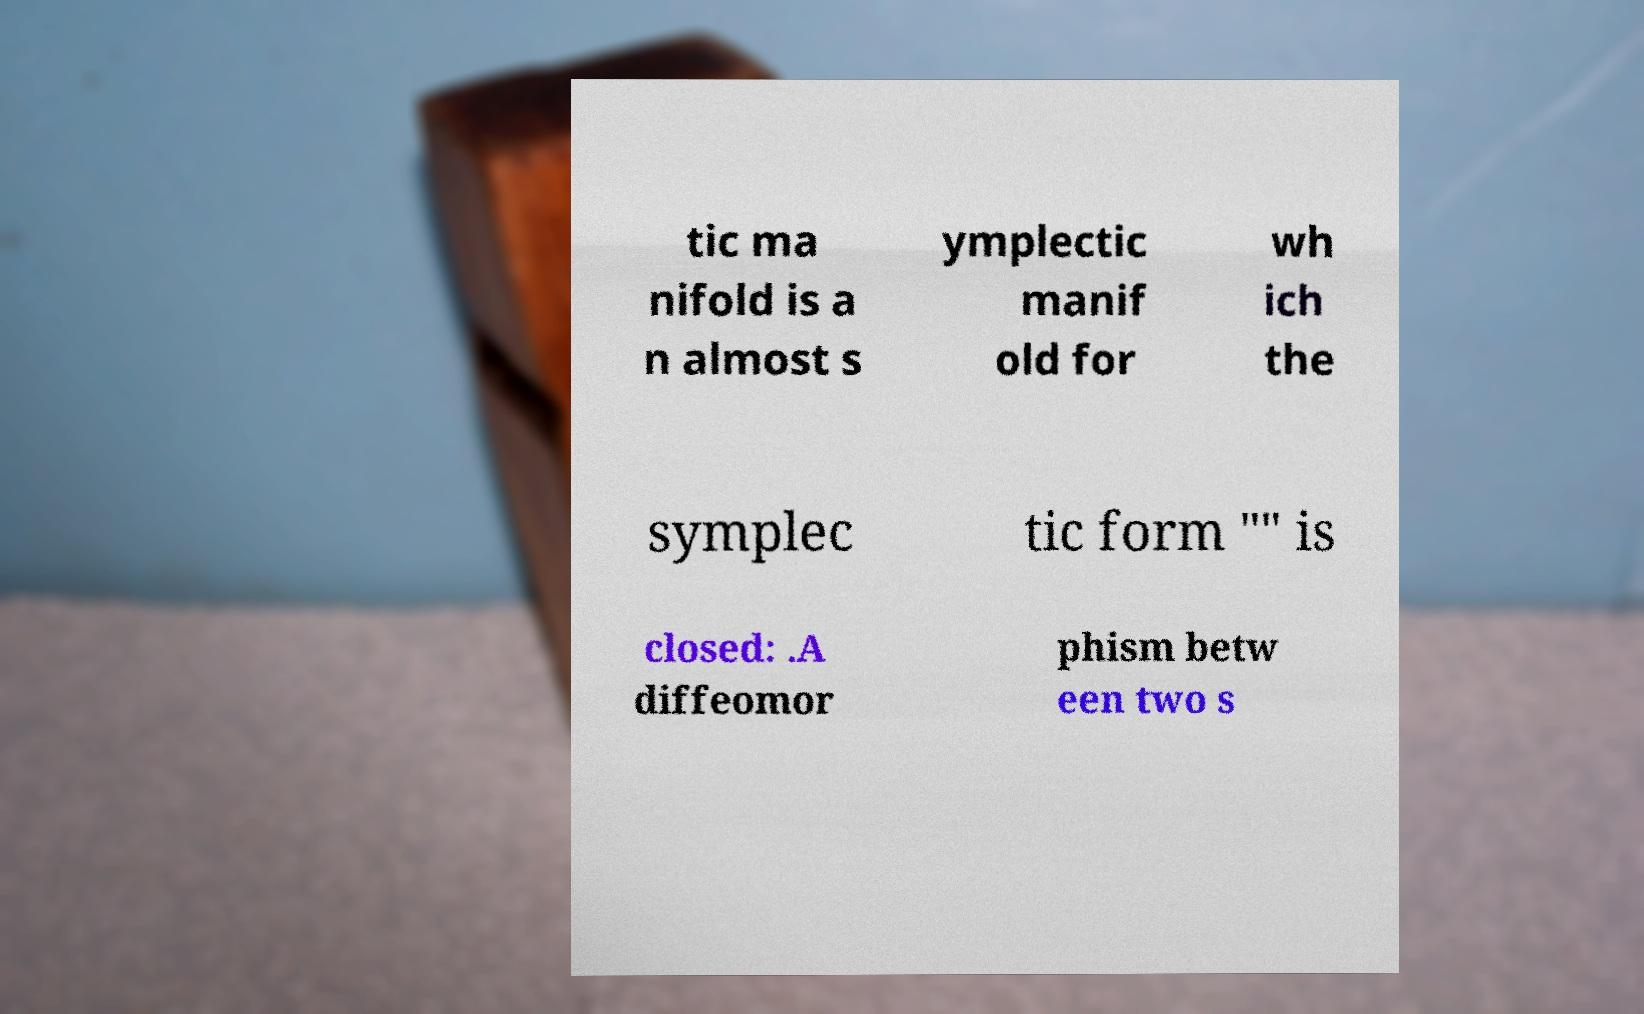I need the written content from this picture converted into text. Can you do that? tic ma nifold is a n almost s ymplectic manif old for wh ich the symplec tic form "" is closed: .A diffeomor phism betw een two s 